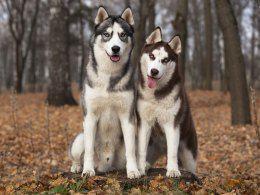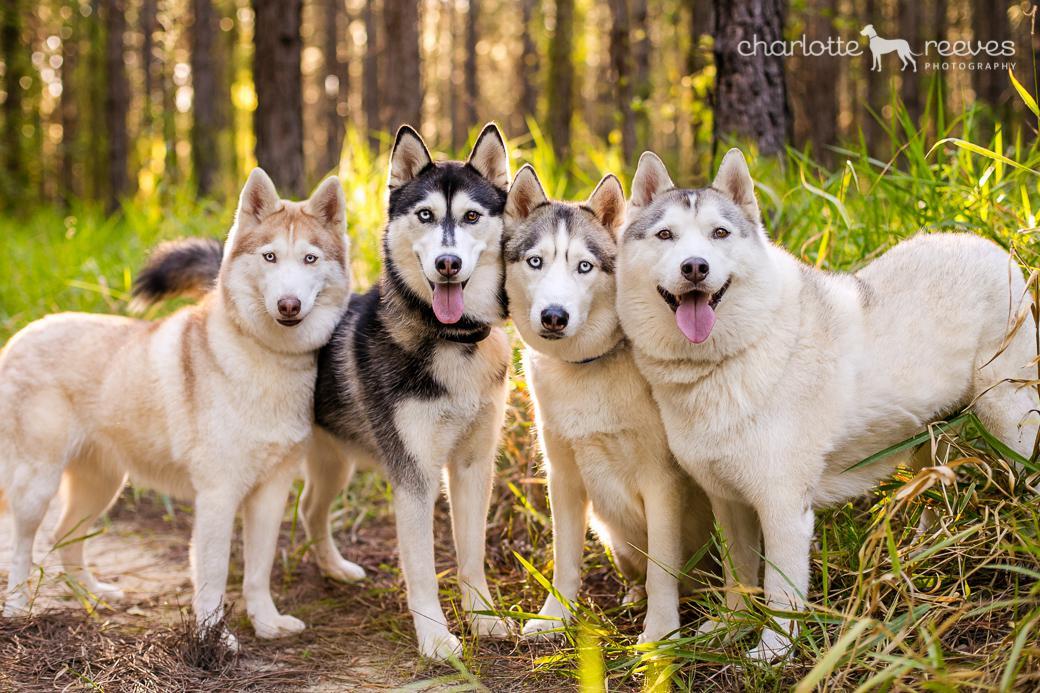The first image is the image on the left, the second image is the image on the right. Examine the images to the left and right. Is the description "There are exactly eight dogs." accurate? Answer yes or no. No. The first image is the image on the left, the second image is the image on the right. Examine the images to the left and right. Is the description "One image shows four husky dogs wearing different colored collars with dangling charms, and at least three of the dogs sit upright and face forward." accurate? Answer yes or no. No. 